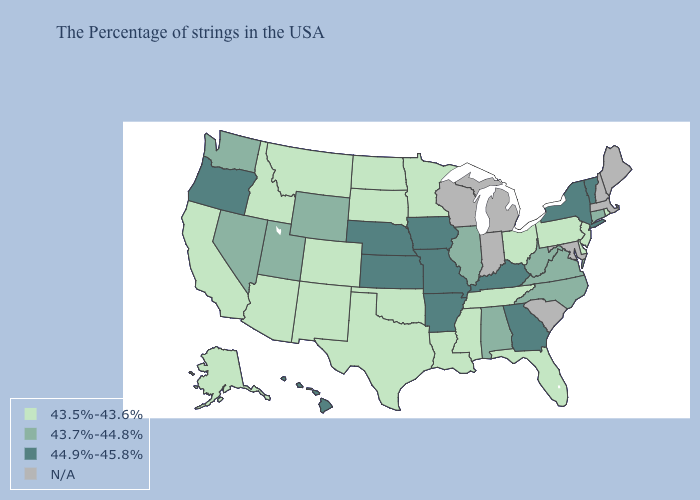Does Hawaii have the highest value in the West?
Keep it brief. Yes. What is the value of South Dakota?
Keep it brief. 43.5%-43.6%. Name the states that have a value in the range 43.7%-44.8%?
Give a very brief answer. Connecticut, Virginia, North Carolina, West Virginia, Alabama, Illinois, Wyoming, Utah, Nevada, Washington. Name the states that have a value in the range 44.9%-45.8%?
Be succinct. Vermont, New York, Georgia, Kentucky, Missouri, Arkansas, Iowa, Kansas, Nebraska, Oregon, Hawaii. What is the highest value in the USA?
Short answer required. 44.9%-45.8%. Among the states that border Alabama , does Mississippi have the highest value?
Be succinct. No. What is the lowest value in the USA?
Concise answer only. 43.5%-43.6%. What is the value of Washington?
Write a very short answer. 43.7%-44.8%. What is the value of Indiana?
Quick response, please. N/A. Name the states that have a value in the range 43.7%-44.8%?
Give a very brief answer. Connecticut, Virginia, North Carolina, West Virginia, Alabama, Illinois, Wyoming, Utah, Nevada, Washington. What is the value of North Carolina?
Quick response, please. 43.7%-44.8%. Does Ohio have the highest value in the MidWest?
Keep it brief. No. 